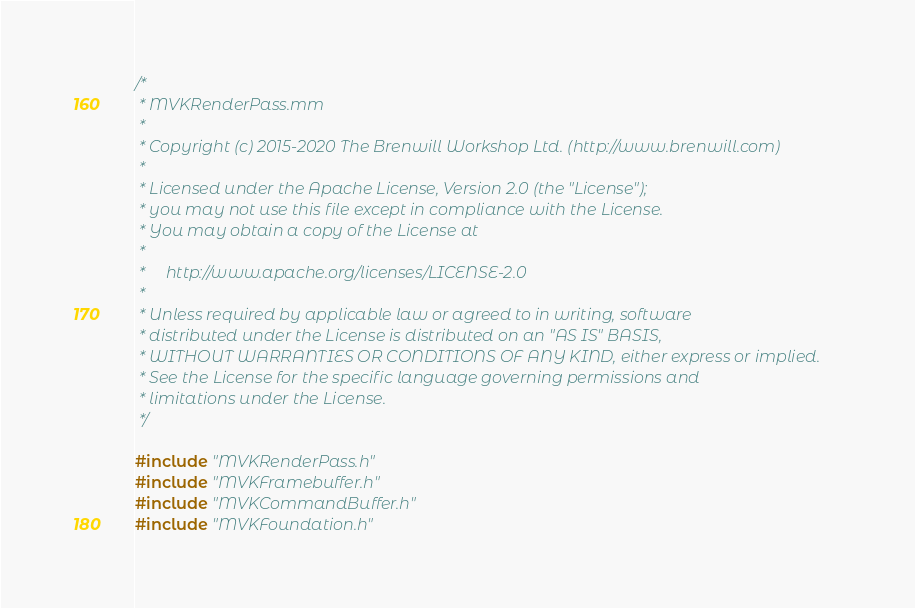Convert code to text. <code><loc_0><loc_0><loc_500><loc_500><_ObjectiveC_>/*
 * MVKRenderPass.mm
 *
 * Copyright (c) 2015-2020 The Brenwill Workshop Ltd. (http://www.brenwill.com)
 *
 * Licensed under the Apache License, Version 2.0 (the "License");
 * you may not use this file except in compliance with the License.
 * You may obtain a copy of the License at
 * 
 *     http://www.apache.org/licenses/LICENSE-2.0
 * 
 * Unless required by applicable law or agreed to in writing, software
 * distributed under the License is distributed on an "AS IS" BASIS,
 * WITHOUT WARRANTIES OR CONDITIONS OF ANY KIND, either express or implied.
 * See the License for the specific language governing permissions and
 * limitations under the License.
 */

#include "MVKRenderPass.h"
#include "MVKFramebuffer.h"
#include "MVKCommandBuffer.h"
#include "MVKFoundation.h"</code> 